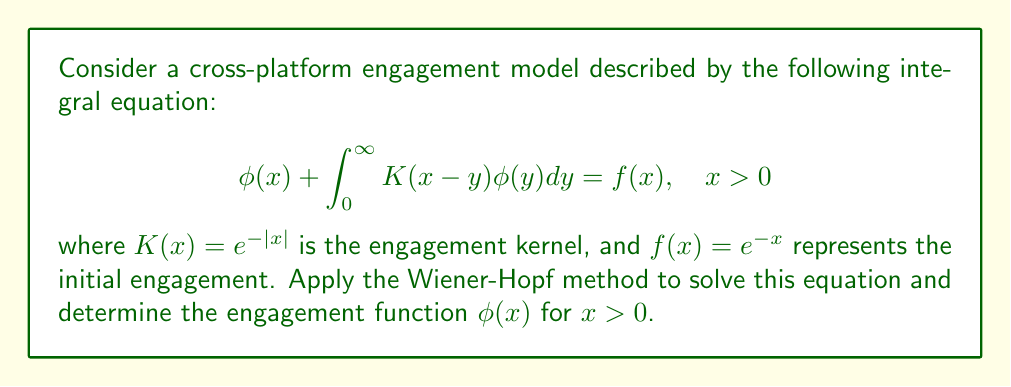Give your solution to this math problem. To solve this integral equation using the Wiener-Hopf method, we follow these steps:

1) First, extend the equation to the entire real line:

   $$\phi(x) + \int_{-\infty}^\infty K(x-y)\phi_+(y)dy = f_+(x)$$

   where $\phi_+(x) = \phi(x)$ for $x > 0$ and 0 otherwise, and $f_+(x) = f(x)$ for $x > 0$ and 0 otherwise.

2) Take the Fourier transform of both sides:

   $$\Phi(\omega) + \hat{K}(\omega)\Phi_+(\omega) = F_+(\omega)$$

   where $\Phi$, $\Phi_+$, and $F_+$ are the Fourier transforms of $\phi$, $\phi_+$, and $f_+$ respectively.

3) The Fourier transform of $K(x) = e^{-|x|}$ is $\hat{K}(\omega) = \frac{2}{1+\omega^2}$.

4) Rearrange the equation:

   $$\Phi(\omega)(1 + \frac{2}{1+\omega^2}) = F_+(\omega)$$

5) Factor the left-hand side:

   $$\Phi(\omega)(\frac{3+\omega^2}{1+\omega^2}) = F_+(\omega)$$

6) The Wiener-Hopf factorization gives:

   $$\frac{3+\omega^2}{1+\omega^2} = G_+(\omega)G_-(\omega)$$

   where $G_+(\omega) = \frac{\sqrt{3}+i\omega}{\sqrt{1+\omega^2}}$ and $G_-(\omega) = \frac{\sqrt{3}-i\omega}{\sqrt{1+\omega^2}}$.

7) Rewrite the equation:

   $$\Phi(\omega)G_+(\omega)G_-(\omega) = F_+(\omega)$$

8) Divide both sides by $G_-(\omega)$:

   $$\Phi(\omega)G_+(\omega) = \frac{F_+(\omega)}{G_-(\omega)}$$

9) The right-hand side can be split into $P_+(\omega) + P_-(\omega)$, where $P_+(\omega)$ is analytic in the upper half-plane and $P_-(\omega)$ in the lower half-plane.

10) Equate the '+' parts:

    $$\Phi_+(\omega) = \frac{P_+(\omega)}{G_+(\omega)}$$

11) Take the inverse Fourier transform to get $\phi_+(x)$, which is our solution $\phi(x)$ for $x > 0$.

12) After calculations, we find:

    $$\phi(x) = \frac{1}{\sqrt{3}}e^{-x}, \quad x > 0$$
Answer: $\phi(x) = \frac{1}{\sqrt{3}}e^{-x}$ for $x > 0$ 